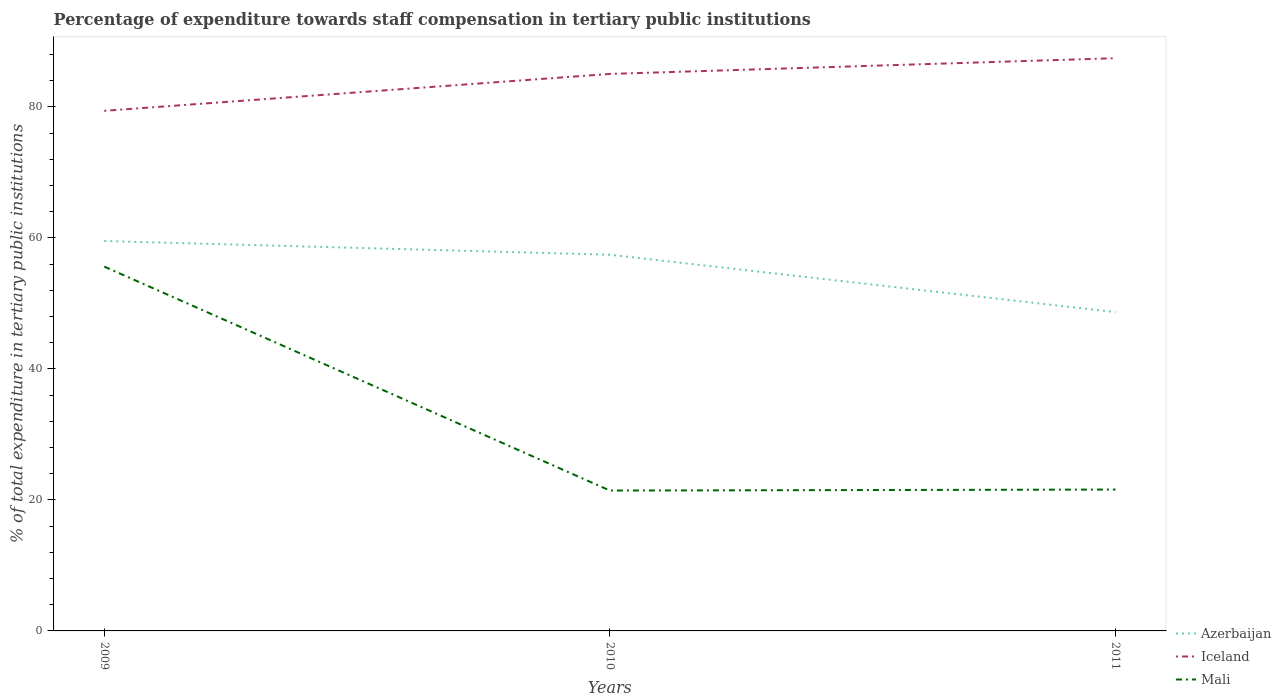Does the line corresponding to Azerbaijan intersect with the line corresponding to Iceland?
Ensure brevity in your answer.  No. Is the number of lines equal to the number of legend labels?
Offer a terse response. Yes. Across all years, what is the maximum percentage of expenditure towards staff compensation in Iceland?
Provide a succinct answer. 79.42. What is the total percentage of expenditure towards staff compensation in Iceland in the graph?
Offer a terse response. -5.63. What is the difference between the highest and the second highest percentage of expenditure towards staff compensation in Azerbaijan?
Your answer should be very brief. 10.86. How many lines are there?
Your answer should be compact. 3. Does the graph contain grids?
Your answer should be compact. No. Where does the legend appear in the graph?
Make the answer very short. Bottom right. How many legend labels are there?
Ensure brevity in your answer.  3. What is the title of the graph?
Give a very brief answer. Percentage of expenditure towards staff compensation in tertiary public institutions. Does "Belgium" appear as one of the legend labels in the graph?
Keep it short and to the point. No. What is the label or title of the Y-axis?
Your answer should be very brief. % of total expenditure in tertiary public institutions. What is the % of total expenditure in tertiary public institutions in Azerbaijan in 2009?
Your response must be concise. 59.54. What is the % of total expenditure in tertiary public institutions of Iceland in 2009?
Your answer should be very brief. 79.42. What is the % of total expenditure in tertiary public institutions of Mali in 2009?
Keep it short and to the point. 55.63. What is the % of total expenditure in tertiary public institutions of Azerbaijan in 2010?
Offer a very short reply. 57.44. What is the % of total expenditure in tertiary public institutions in Iceland in 2010?
Provide a short and direct response. 85.05. What is the % of total expenditure in tertiary public institutions in Mali in 2010?
Your answer should be compact. 21.43. What is the % of total expenditure in tertiary public institutions of Azerbaijan in 2011?
Ensure brevity in your answer.  48.68. What is the % of total expenditure in tertiary public institutions of Iceland in 2011?
Offer a very short reply. 87.45. What is the % of total expenditure in tertiary public institutions in Mali in 2011?
Provide a short and direct response. 21.59. Across all years, what is the maximum % of total expenditure in tertiary public institutions in Azerbaijan?
Your answer should be very brief. 59.54. Across all years, what is the maximum % of total expenditure in tertiary public institutions of Iceland?
Your answer should be very brief. 87.45. Across all years, what is the maximum % of total expenditure in tertiary public institutions of Mali?
Offer a terse response. 55.63. Across all years, what is the minimum % of total expenditure in tertiary public institutions in Azerbaijan?
Ensure brevity in your answer.  48.68. Across all years, what is the minimum % of total expenditure in tertiary public institutions of Iceland?
Offer a very short reply. 79.42. Across all years, what is the minimum % of total expenditure in tertiary public institutions in Mali?
Provide a short and direct response. 21.43. What is the total % of total expenditure in tertiary public institutions in Azerbaijan in the graph?
Your answer should be compact. 165.66. What is the total % of total expenditure in tertiary public institutions in Iceland in the graph?
Ensure brevity in your answer.  251.92. What is the total % of total expenditure in tertiary public institutions in Mali in the graph?
Your response must be concise. 98.65. What is the difference between the % of total expenditure in tertiary public institutions of Azerbaijan in 2009 and that in 2010?
Your response must be concise. 2.09. What is the difference between the % of total expenditure in tertiary public institutions of Iceland in 2009 and that in 2010?
Give a very brief answer. -5.63. What is the difference between the % of total expenditure in tertiary public institutions of Mali in 2009 and that in 2010?
Keep it short and to the point. 34.2. What is the difference between the % of total expenditure in tertiary public institutions of Azerbaijan in 2009 and that in 2011?
Your response must be concise. 10.86. What is the difference between the % of total expenditure in tertiary public institutions in Iceland in 2009 and that in 2011?
Your answer should be compact. -8.04. What is the difference between the % of total expenditure in tertiary public institutions of Mali in 2009 and that in 2011?
Make the answer very short. 34.04. What is the difference between the % of total expenditure in tertiary public institutions in Azerbaijan in 2010 and that in 2011?
Your answer should be compact. 8.76. What is the difference between the % of total expenditure in tertiary public institutions of Iceland in 2010 and that in 2011?
Give a very brief answer. -2.4. What is the difference between the % of total expenditure in tertiary public institutions in Mali in 2010 and that in 2011?
Offer a very short reply. -0.16. What is the difference between the % of total expenditure in tertiary public institutions in Azerbaijan in 2009 and the % of total expenditure in tertiary public institutions in Iceland in 2010?
Ensure brevity in your answer.  -25.51. What is the difference between the % of total expenditure in tertiary public institutions of Azerbaijan in 2009 and the % of total expenditure in tertiary public institutions of Mali in 2010?
Your answer should be compact. 38.1. What is the difference between the % of total expenditure in tertiary public institutions in Iceland in 2009 and the % of total expenditure in tertiary public institutions in Mali in 2010?
Make the answer very short. 57.98. What is the difference between the % of total expenditure in tertiary public institutions of Azerbaijan in 2009 and the % of total expenditure in tertiary public institutions of Iceland in 2011?
Your answer should be very brief. -27.92. What is the difference between the % of total expenditure in tertiary public institutions of Azerbaijan in 2009 and the % of total expenditure in tertiary public institutions of Mali in 2011?
Ensure brevity in your answer.  37.95. What is the difference between the % of total expenditure in tertiary public institutions in Iceland in 2009 and the % of total expenditure in tertiary public institutions in Mali in 2011?
Provide a succinct answer. 57.83. What is the difference between the % of total expenditure in tertiary public institutions in Azerbaijan in 2010 and the % of total expenditure in tertiary public institutions in Iceland in 2011?
Your response must be concise. -30.01. What is the difference between the % of total expenditure in tertiary public institutions of Azerbaijan in 2010 and the % of total expenditure in tertiary public institutions of Mali in 2011?
Your answer should be compact. 35.85. What is the difference between the % of total expenditure in tertiary public institutions in Iceland in 2010 and the % of total expenditure in tertiary public institutions in Mali in 2011?
Give a very brief answer. 63.46. What is the average % of total expenditure in tertiary public institutions in Azerbaijan per year?
Give a very brief answer. 55.22. What is the average % of total expenditure in tertiary public institutions of Iceland per year?
Your answer should be very brief. 83.97. What is the average % of total expenditure in tertiary public institutions in Mali per year?
Keep it short and to the point. 32.88. In the year 2009, what is the difference between the % of total expenditure in tertiary public institutions in Azerbaijan and % of total expenditure in tertiary public institutions in Iceland?
Provide a short and direct response. -19.88. In the year 2009, what is the difference between the % of total expenditure in tertiary public institutions of Azerbaijan and % of total expenditure in tertiary public institutions of Mali?
Ensure brevity in your answer.  3.91. In the year 2009, what is the difference between the % of total expenditure in tertiary public institutions of Iceland and % of total expenditure in tertiary public institutions of Mali?
Offer a very short reply. 23.79. In the year 2010, what is the difference between the % of total expenditure in tertiary public institutions of Azerbaijan and % of total expenditure in tertiary public institutions of Iceland?
Keep it short and to the point. -27.61. In the year 2010, what is the difference between the % of total expenditure in tertiary public institutions of Azerbaijan and % of total expenditure in tertiary public institutions of Mali?
Ensure brevity in your answer.  36.01. In the year 2010, what is the difference between the % of total expenditure in tertiary public institutions of Iceland and % of total expenditure in tertiary public institutions of Mali?
Your answer should be very brief. 63.62. In the year 2011, what is the difference between the % of total expenditure in tertiary public institutions in Azerbaijan and % of total expenditure in tertiary public institutions in Iceland?
Ensure brevity in your answer.  -38.77. In the year 2011, what is the difference between the % of total expenditure in tertiary public institutions of Azerbaijan and % of total expenditure in tertiary public institutions of Mali?
Your response must be concise. 27.09. In the year 2011, what is the difference between the % of total expenditure in tertiary public institutions in Iceland and % of total expenditure in tertiary public institutions in Mali?
Your answer should be compact. 65.86. What is the ratio of the % of total expenditure in tertiary public institutions in Azerbaijan in 2009 to that in 2010?
Keep it short and to the point. 1.04. What is the ratio of the % of total expenditure in tertiary public institutions of Iceland in 2009 to that in 2010?
Provide a short and direct response. 0.93. What is the ratio of the % of total expenditure in tertiary public institutions in Mali in 2009 to that in 2010?
Your answer should be very brief. 2.6. What is the ratio of the % of total expenditure in tertiary public institutions in Azerbaijan in 2009 to that in 2011?
Offer a very short reply. 1.22. What is the ratio of the % of total expenditure in tertiary public institutions in Iceland in 2009 to that in 2011?
Your answer should be very brief. 0.91. What is the ratio of the % of total expenditure in tertiary public institutions of Mali in 2009 to that in 2011?
Offer a very short reply. 2.58. What is the ratio of the % of total expenditure in tertiary public institutions in Azerbaijan in 2010 to that in 2011?
Provide a succinct answer. 1.18. What is the ratio of the % of total expenditure in tertiary public institutions of Iceland in 2010 to that in 2011?
Make the answer very short. 0.97. What is the difference between the highest and the second highest % of total expenditure in tertiary public institutions of Azerbaijan?
Ensure brevity in your answer.  2.09. What is the difference between the highest and the second highest % of total expenditure in tertiary public institutions in Iceland?
Your response must be concise. 2.4. What is the difference between the highest and the second highest % of total expenditure in tertiary public institutions in Mali?
Keep it short and to the point. 34.04. What is the difference between the highest and the lowest % of total expenditure in tertiary public institutions in Azerbaijan?
Give a very brief answer. 10.86. What is the difference between the highest and the lowest % of total expenditure in tertiary public institutions in Iceland?
Ensure brevity in your answer.  8.04. What is the difference between the highest and the lowest % of total expenditure in tertiary public institutions of Mali?
Provide a succinct answer. 34.2. 